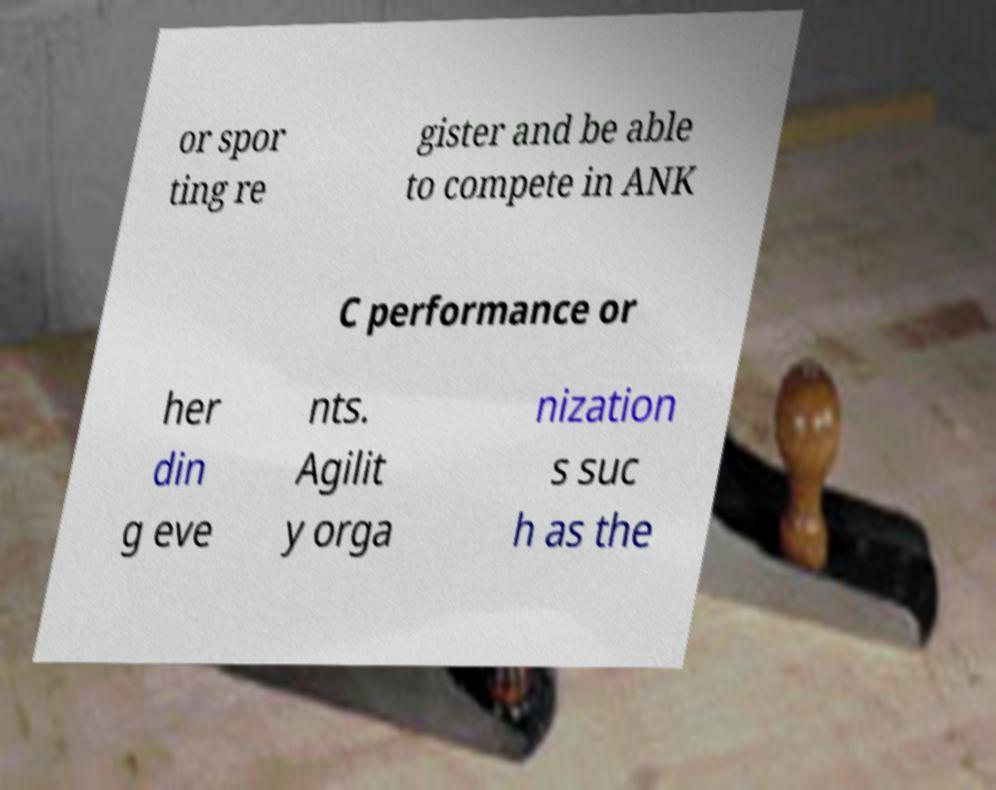For documentation purposes, I need the text within this image transcribed. Could you provide that? or spor ting re gister and be able to compete in ANK C performance or her din g eve nts. Agilit y orga nization s suc h as the 